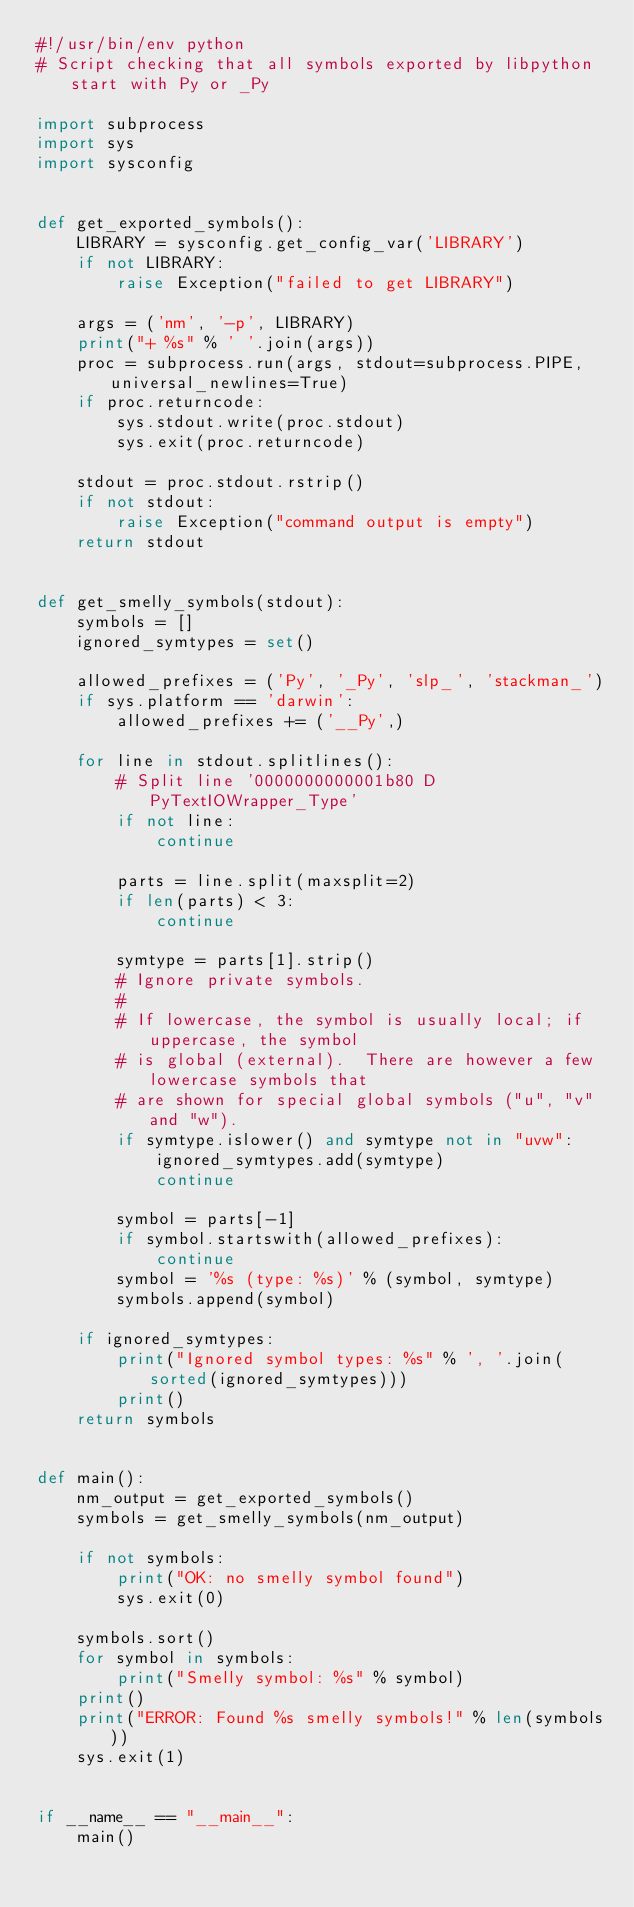<code> <loc_0><loc_0><loc_500><loc_500><_Python_>#!/usr/bin/env python
# Script checking that all symbols exported by libpython start with Py or _Py

import subprocess
import sys
import sysconfig


def get_exported_symbols():
    LIBRARY = sysconfig.get_config_var('LIBRARY')
    if not LIBRARY:
        raise Exception("failed to get LIBRARY")

    args = ('nm', '-p', LIBRARY)
    print("+ %s" % ' '.join(args))
    proc = subprocess.run(args, stdout=subprocess.PIPE, universal_newlines=True)
    if proc.returncode:
        sys.stdout.write(proc.stdout)
        sys.exit(proc.returncode)

    stdout = proc.stdout.rstrip()
    if not stdout:
        raise Exception("command output is empty")
    return stdout


def get_smelly_symbols(stdout):
    symbols = []
    ignored_symtypes = set()

    allowed_prefixes = ('Py', '_Py', 'slp_', 'stackman_')
    if sys.platform == 'darwin':
        allowed_prefixes += ('__Py',)

    for line in stdout.splitlines():
        # Split line '0000000000001b80 D PyTextIOWrapper_Type'
        if not line:
            continue

        parts = line.split(maxsplit=2)
        if len(parts) < 3:
            continue

        symtype = parts[1].strip()
        # Ignore private symbols.
        #
        # If lowercase, the symbol is usually local; if uppercase, the symbol
        # is global (external).  There are however a few lowercase symbols that
        # are shown for special global symbols ("u", "v" and "w").
        if symtype.islower() and symtype not in "uvw":
            ignored_symtypes.add(symtype)
            continue

        symbol = parts[-1]
        if symbol.startswith(allowed_prefixes):
            continue
        symbol = '%s (type: %s)' % (symbol, symtype)
        symbols.append(symbol)

    if ignored_symtypes:
        print("Ignored symbol types: %s" % ', '.join(sorted(ignored_symtypes)))
        print()
    return symbols


def main():
    nm_output = get_exported_symbols()
    symbols = get_smelly_symbols(nm_output)

    if not symbols:
        print("OK: no smelly symbol found")
        sys.exit(0)

    symbols.sort()
    for symbol in symbols:
        print("Smelly symbol: %s" % symbol)
    print()
    print("ERROR: Found %s smelly symbols!" % len(symbols))
    sys.exit(1)


if __name__ == "__main__":
    main()
</code> 